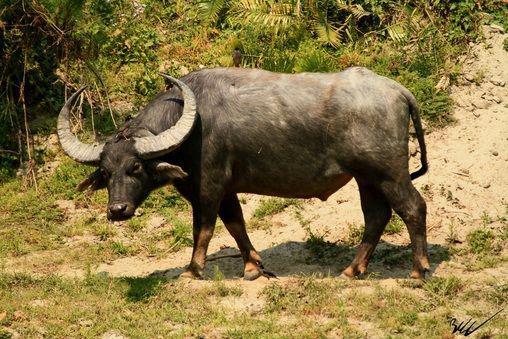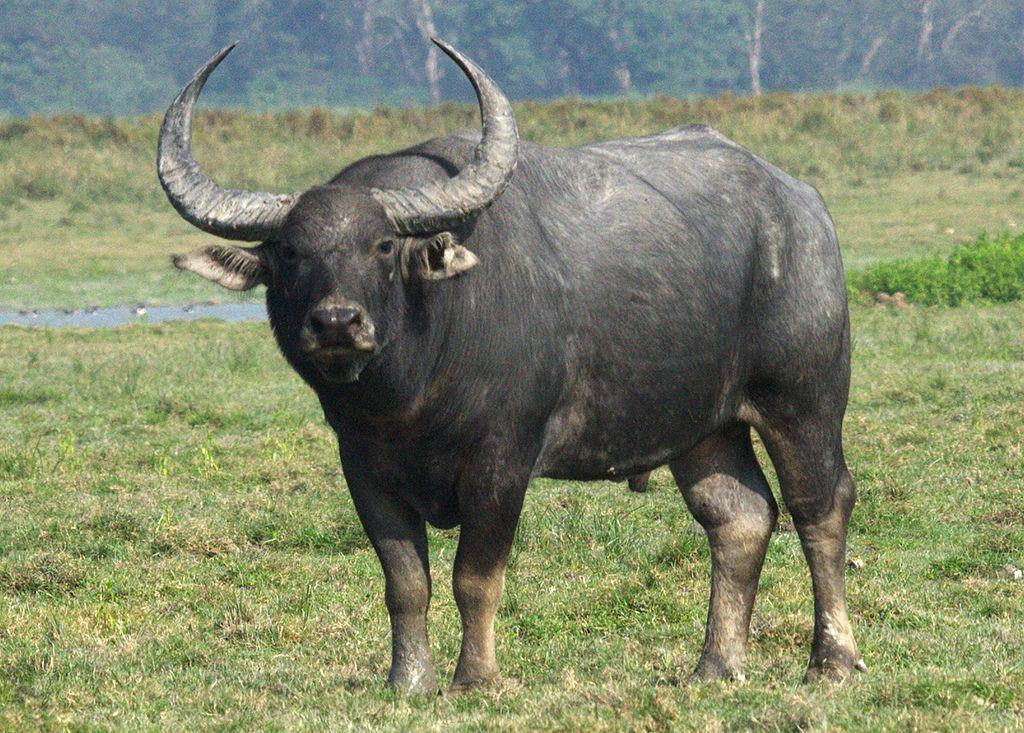The first image is the image on the left, the second image is the image on the right. Given the left and right images, does the statement "Two water buffalo are present in the left image." hold true? Answer yes or no. No. 